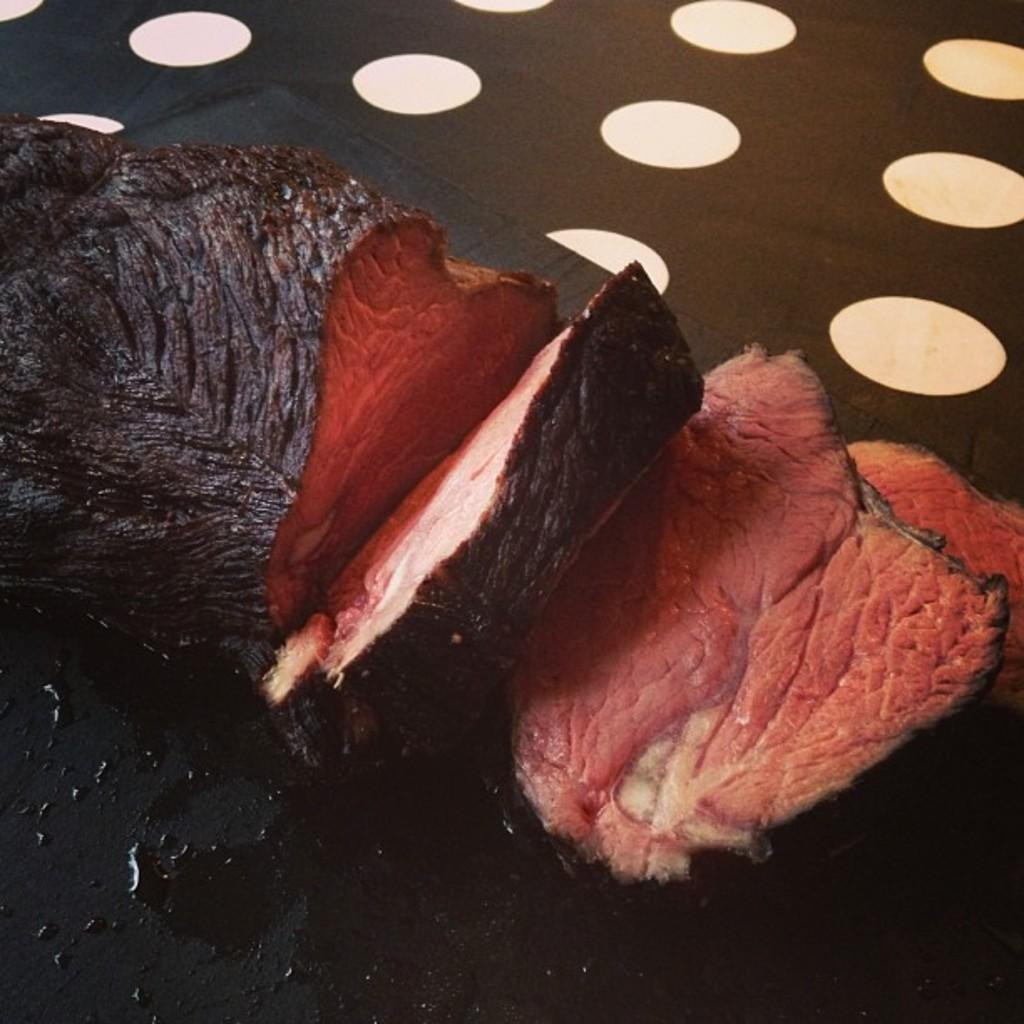What type of material can be seen in the image? Flesh is visible in the image. What color is the surface that the flesh is on? There is a black surface in the image. What can be seen illuminating the scene? Lights are present in the image. What type of coal is visible in the image? There is no coal present in the image. What type of frame surrounds the scene in the image? There is no frame visible in the image. 